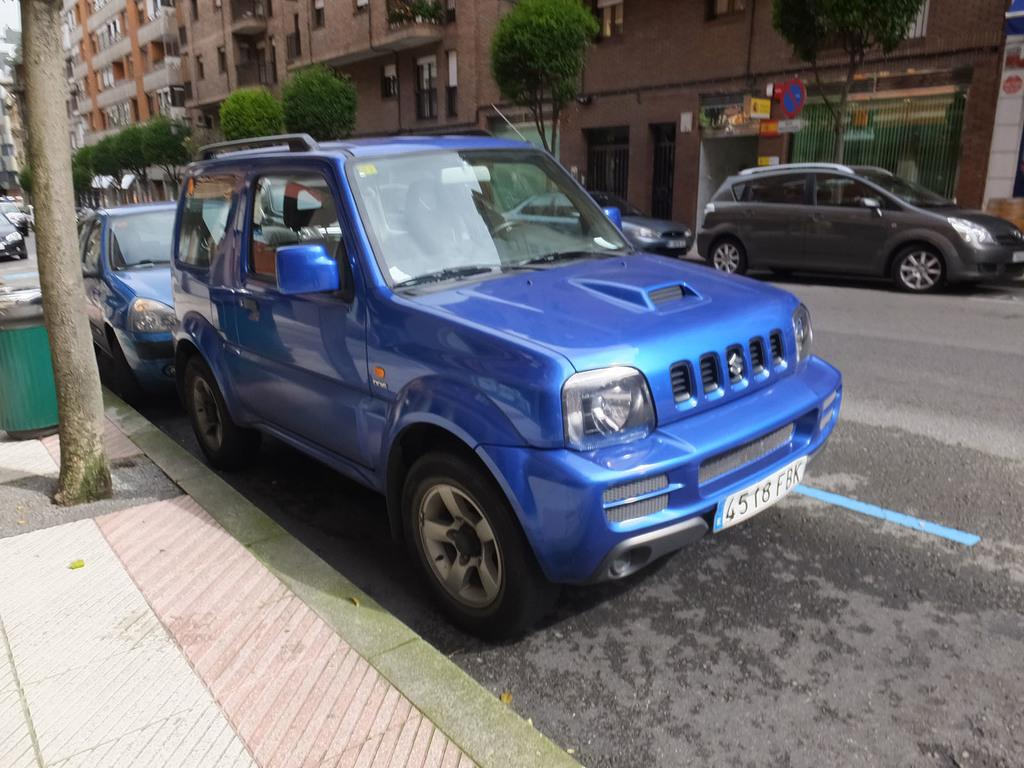What can be seen on the road in the image? There are vehicles on the road in the image. What is visible in the background of the image? There are buildings, trees, banners, and a dustbin in the background of the image. Can you describe any other objects visible in the background of the image? There are other objects visible in the background of the image, but their specific details are not mentioned in the provided facts. What type of farm can be seen in the background of the image? There is no farm present in the image; it features vehicles on the road and various objects in the background. What message does the authority convey through the banners in the image? The provided facts do not mention any specific message or authority related to the banners in the image. 